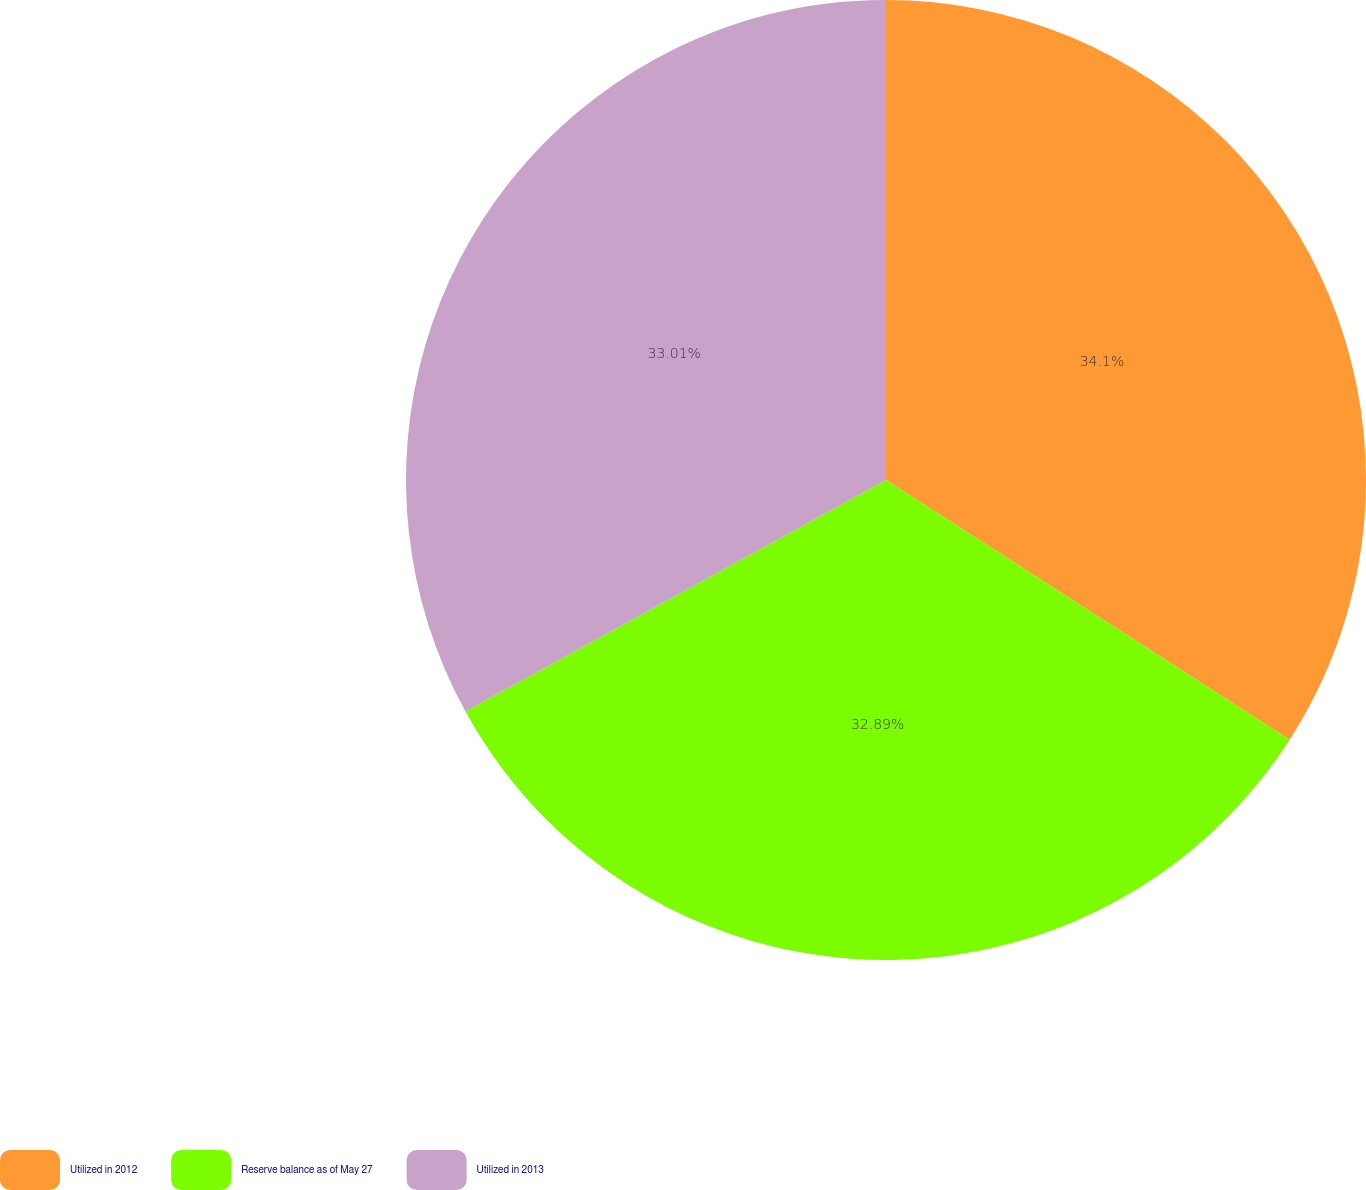Convert chart. <chart><loc_0><loc_0><loc_500><loc_500><pie_chart><fcel>Utilized in 2012<fcel>Reserve balance as of May 27<fcel>Utilized in 2013<nl><fcel>34.1%<fcel>32.89%<fcel>33.01%<nl></chart> 